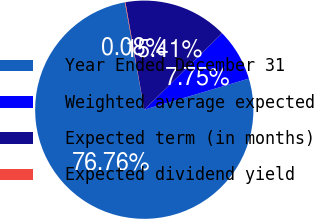Convert chart. <chart><loc_0><loc_0><loc_500><loc_500><pie_chart><fcel>Year Ended December 31<fcel>Weighted average expected<fcel>Expected term (in months)<fcel>Expected dividend yield<nl><fcel>76.76%<fcel>7.75%<fcel>15.41%<fcel>0.08%<nl></chart> 